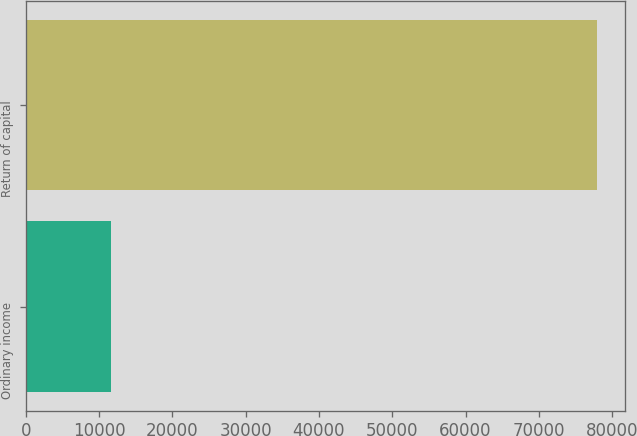<chart> <loc_0><loc_0><loc_500><loc_500><bar_chart><fcel>Ordinary income<fcel>Return of capital<nl><fcel>11638<fcel>77903<nl></chart> 